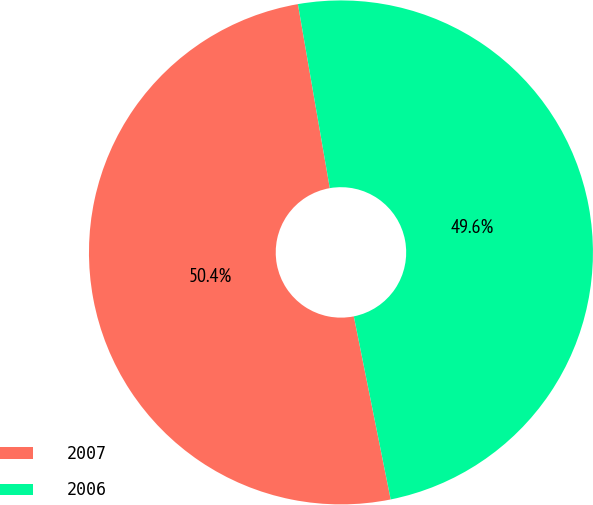Convert chart to OTSL. <chart><loc_0><loc_0><loc_500><loc_500><pie_chart><fcel>2007<fcel>2006<nl><fcel>50.43%<fcel>49.57%<nl></chart> 